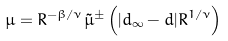Convert formula to latex. <formula><loc_0><loc_0><loc_500><loc_500>\mu = R ^ { - \beta / \nu } \tilde { \mu } ^ { \pm } \left ( | d _ { \infty } - d | R ^ { 1 / \nu } \right )</formula> 